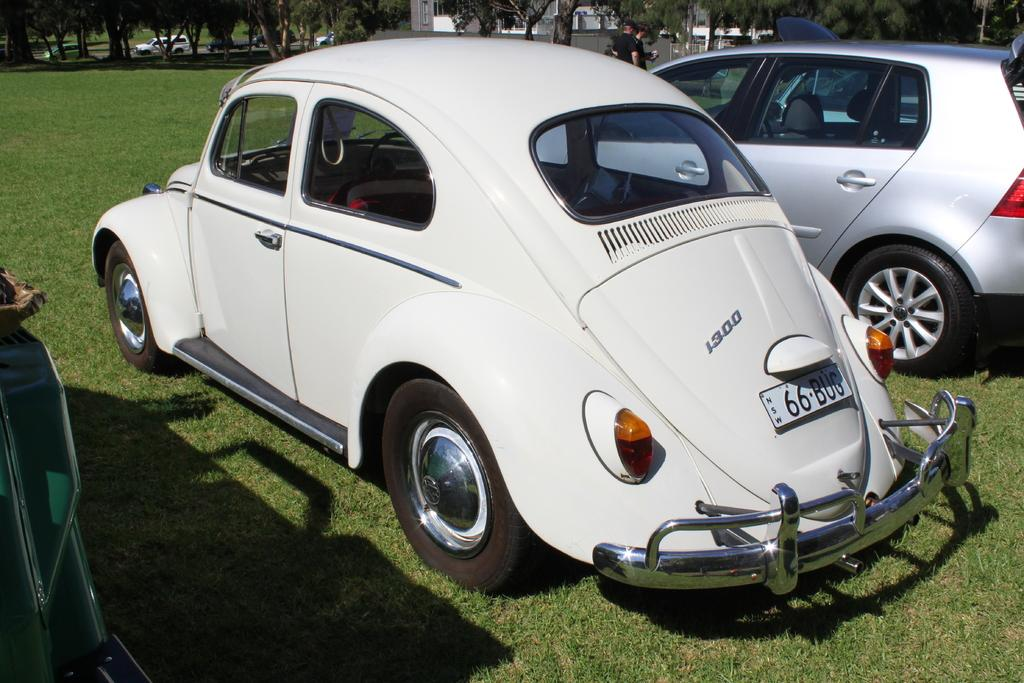What is located in the foreground of the image? There are three vehicles in the foreground of the image. Where are the vehicles situated? The vehicles are on the grass. What can be seen in the background of the image? There are trees and a few vehicles in the background of the image. Are there any people visible in the image? Yes, two men are standing in the background of the image. What type of zephyr can be seen blowing through the image? There is no zephyr present in the image; it is a still image with no indication of wind or air movement. 